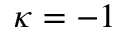Convert formula to latex. <formula><loc_0><loc_0><loc_500><loc_500>\kappa = - 1</formula> 